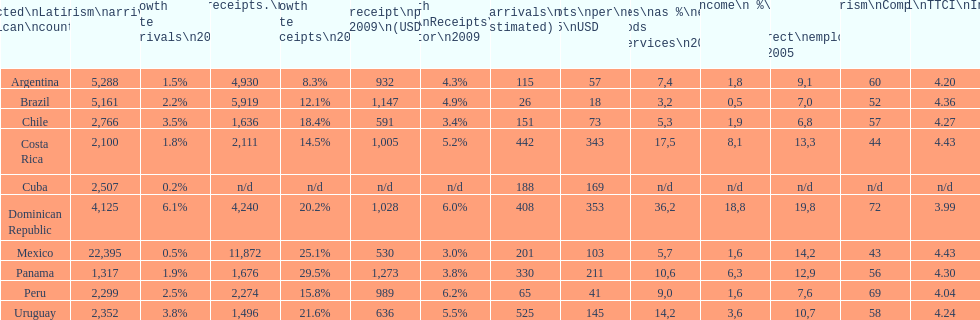Could you help me parse every detail presented in this table? {'header': ['Selected\\nLatin American\\ncountries', 'Internl.\\ntourism\\narrivals\\n2010\\n(x 1000)', 'Growth Rate Arrivals\\n2010', 'Internl.\\ntourism\\nreceipts.\\n2010\\n(USD\\n(x1000)', 'Growth Rate Receipts\\n2010', 'Average\\nreceipt\\nper visitor\\n2009\\n(USD/turista)', 'Growth Rate\\nReceipts\\nper visitor\\n2009', 'Tourist\\narrivals\\nper\\n1000 inhab\\n(estimated) \\n2007', 'Receipts\\nper\\ncapita \\n2005\\nUSD', 'Revenues\\nas\xa0%\\nexports of\\ngoods and\\nservices\\n2003', 'Tourism\\nincome\\n\xa0%\\nGDP\\n2003', '% Direct and\\nindirect\\nemployment\\nin tourism\\n2005', 'World\\nranking\\nTourism\\nCompetitiv.\\nTTCI\\n2011', '2011\\nTTCI\\nIndex'], 'rows': [['Argentina', '5,288', '1.5%', '4,930', '8.3%', '932', '4.3%', '115', '57', '7,4', '1,8', '9,1', '60', '4.20'], ['Brazil', '5,161', '2.2%', '5,919', '12.1%', '1,147', '4.9%', '26', '18', '3,2', '0,5', '7,0', '52', '4.36'], ['Chile', '2,766', '3.5%', '1,636', '18.4%', '591', '3.4%', '151', '73', '5,3', '1,9', '6,8', '57', '4.27'], ['Costa Rica', '2,100', '1.8%', '2,111', '14.5%', '1,005', '5.2%', '442', '343', '17,5', '8,1', '13,3', '44', '4.43'], ['Cuba', '2,507', '0.2%', 'n/d', 'n/d', 'n/d', 'n/d', '188', '169', 'n/d', 'n/d', 'n/d', 'n/d', 'n/d'], ['Dominican Republic', '4,125', '6.1%', '4,240', '20.2%', '1,028', '6.0%', '408', '353', '36,2', '18,8', '19,8', '72', '3.99'], ['Mexico', '22,395', '0.5%', '11,872', '25.1%', '530', '3.0%', '201', '103', '5,7', '1,6', '14,2', '43', '4.43'], ['Panama', '1,317', '1.9%', '1,676', '29.5%', '1,273', '3.8%', '330', '211', '10,6', '6,3', '12,9', '56', '4.30'], ['Peru', '2,299', '2.5%', '2,274', '15.8%', '989', '6.2%', '65', '41', '9,0', '1,6', '7,6', '69', '4.04'], ['Uruguay', '2,352', '3.8%', '1,496', '21.6%', '636', '5.5%', '525', '145', '14,2', '3,6', '10,7', '58', '4.24']]} What was the average amount of dollars brazil obtained per visitor in 2009? 1,147. 